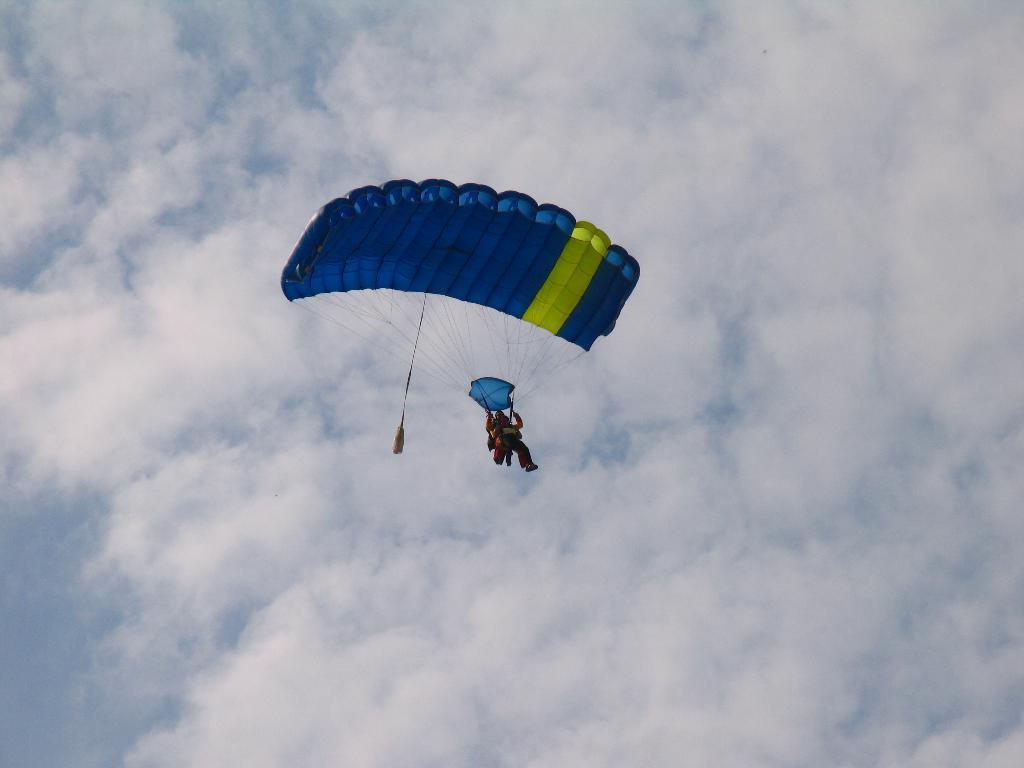Describe this image in one or two sentences. In this image we can see a person parasailing in the sky which looks cloudy. 